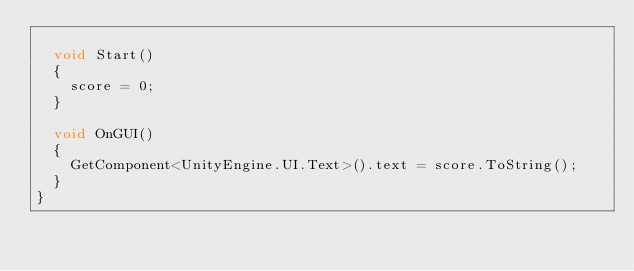Convert code to text. <code><loc_0><loc_0><loc_500><loc_500><_C#_>
	void Start()
	{
		score = 0;
	}

	void OnGUI()
	{
		GetComponent<UnityEngine.UI.Text>().text = score.ToString();
	}
}</code> 